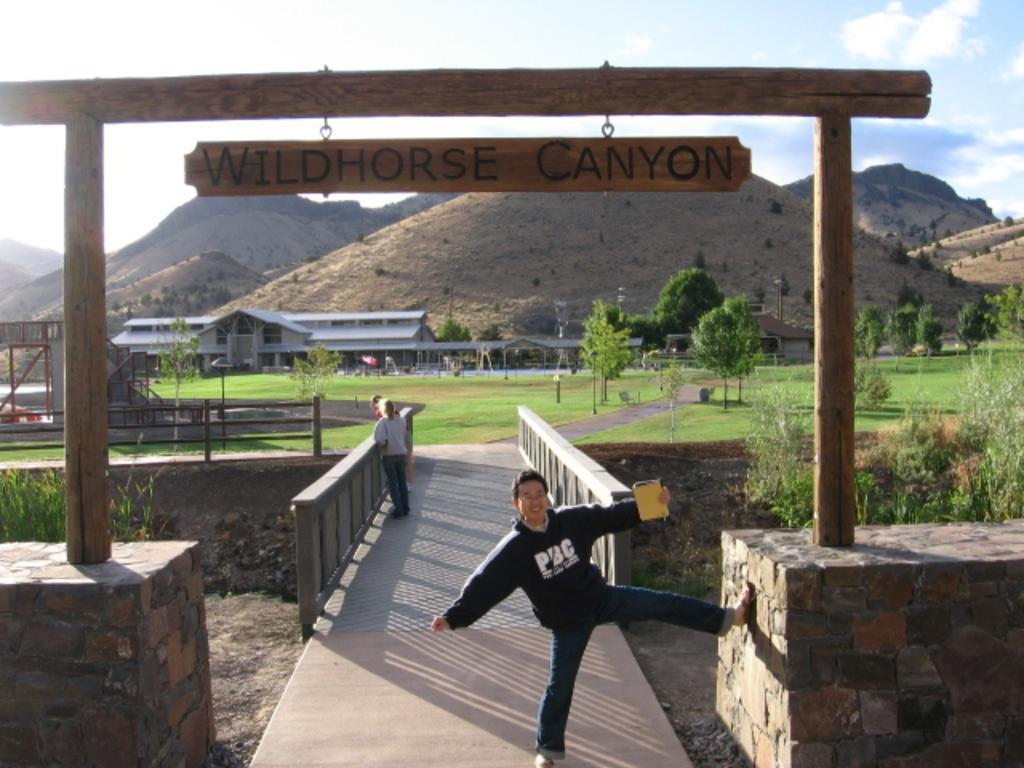In one or two sentences, can you explain what this image depicts? In the center of the image we can see a man standing and holding a book in his hand. In the background there is a bridge and we can see people standing on the bridge. At the top there is a board. In the background there are sheds, trees, hills, bushes and sky. 